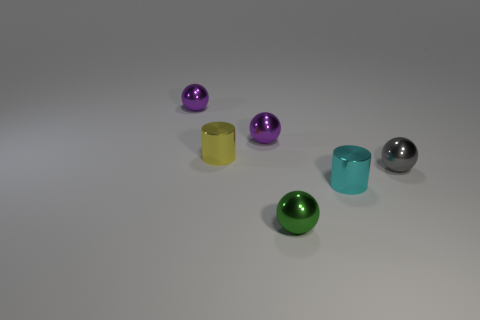Add 3 small yellow metal cylinders. How many objects exist? 9 Subtract all balls. How many objects are left? 2 Subtract all gray things. Subtract all small cyan blocks. How many objects are left? 5 Add 6 cylinders. How many cylinders are left? 8 Add 4 brown objects. How many brown objects exist? 4 Subtract 1 cyan cylinders. How many objects are left? 5 